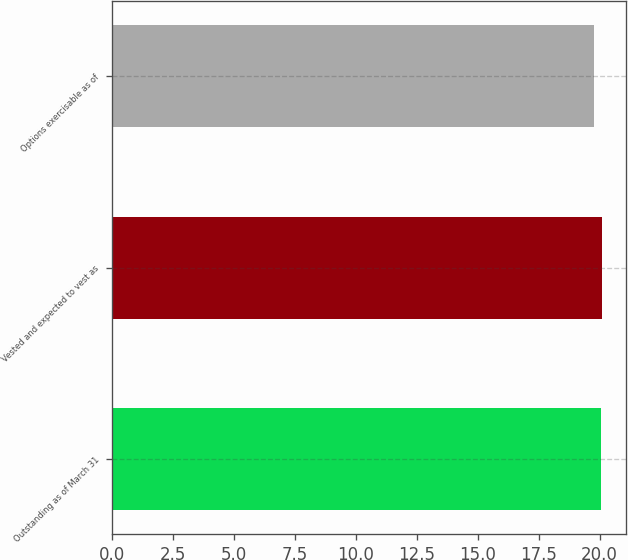Convert chart. <chart><loc_0><loc_0><loc_500><loc_500><bar_chart><fcel>Outstanding as of March 31<fcel>Vested and expected to vest as<fcel>Options exercisable as of<nl><fcel>20.06<fcel>20.09<fcel>19.79<nl></chart> 